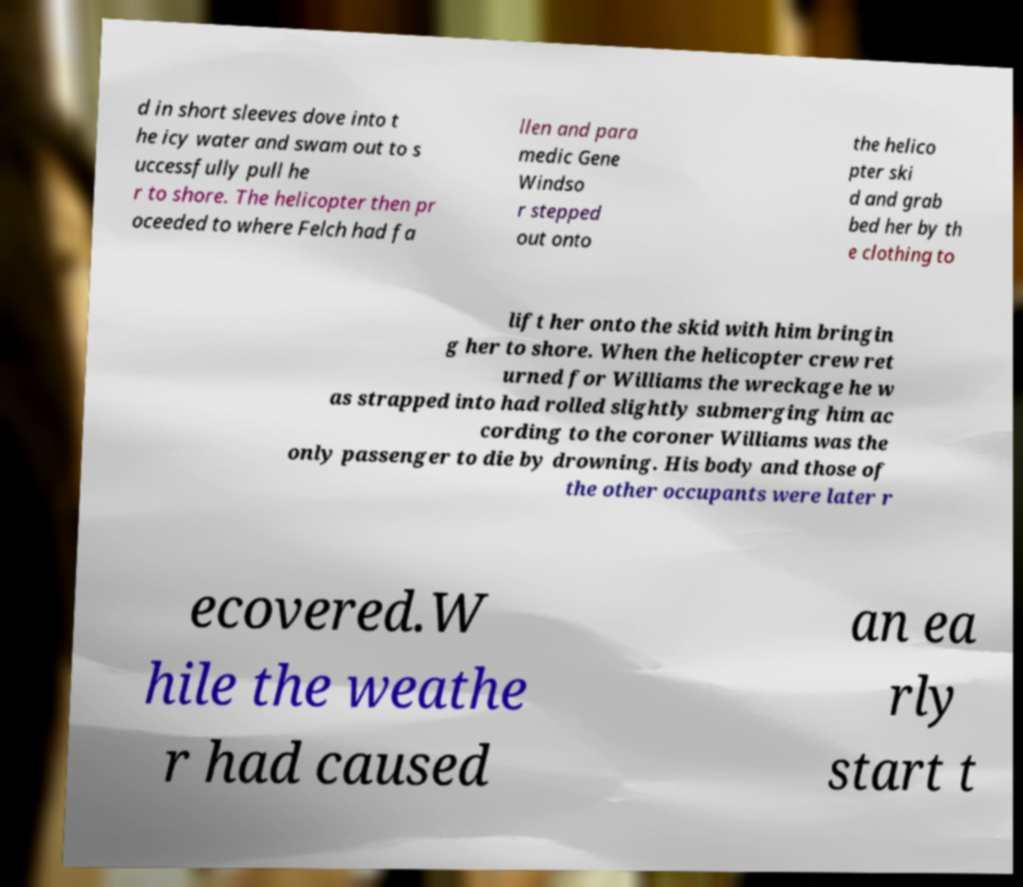There's text embedded in this image that I need extracted. Can you transcribe it verbatim? d in short sleeves dove into t he icy water and swam out to s uccessfully pull he r to shore. The helicopter then pr oceeded to where Felch had fa llen and para medic Gene Windso r stepped out onto the helico pter ski d and grab bed her by th e clothing to lift her onto the skid with him bringin g her to shore. When the helicopter crew ret urned for Williams the wreckage he w as strapped into had rolled slightly submerging him ac cording to the coroner Williams was the only passenger to die by drowning. His body and those of the other occupants were later r ecovered.W hile the weathe r had caused an ea rly start t 